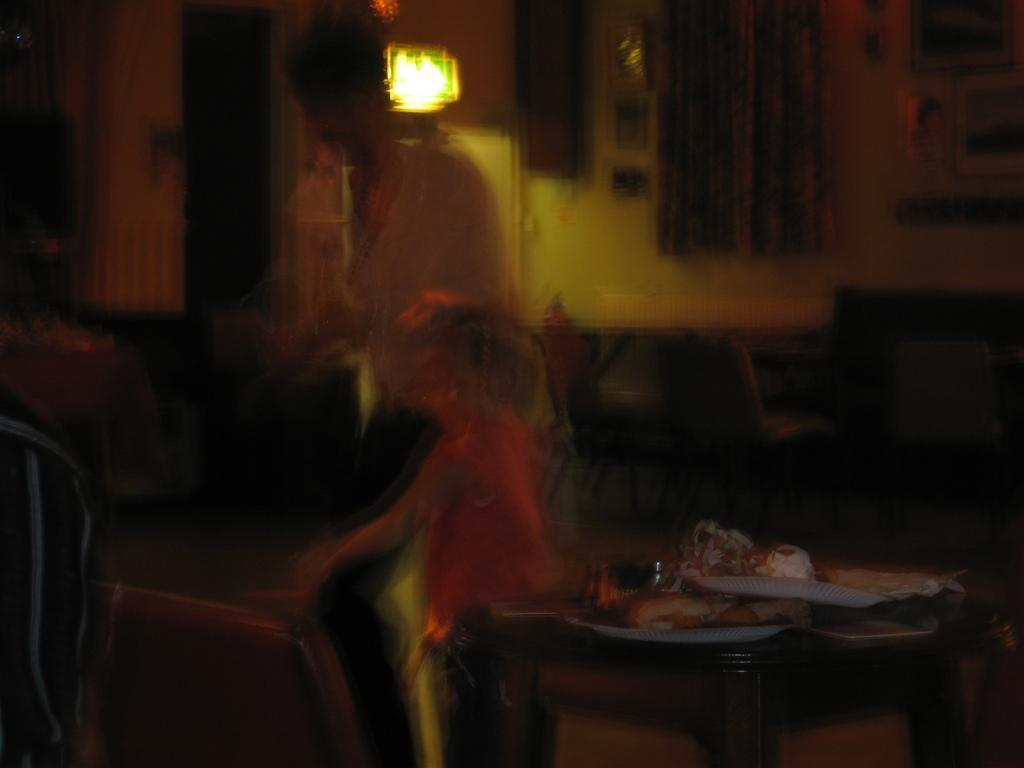Who are the people in the image? There are two people in the image: a woman and a kid. What is present in the image besides the people? There is a table in the image. Can you describe the lighting in the image? There is a light in the background of the image. On which side of the image is a person located? There is a person on the left side of the image. What type of operation is being performed by the scarecrow in the image? There is no scarecrow present in the image, so no operation can be observed. Who is the actor in the image? The image does not depict a performance or an actor; it features a woman and a kid in a setting with a table and a light. 